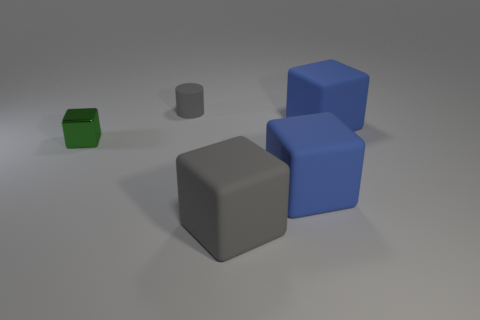Which objects are closest to the gray cylinder in the center of the image? The objects closest to the central gray cylinder are two blue cubes, one positioned slightly behind and to the left, and the other to the right of the cylinder. 